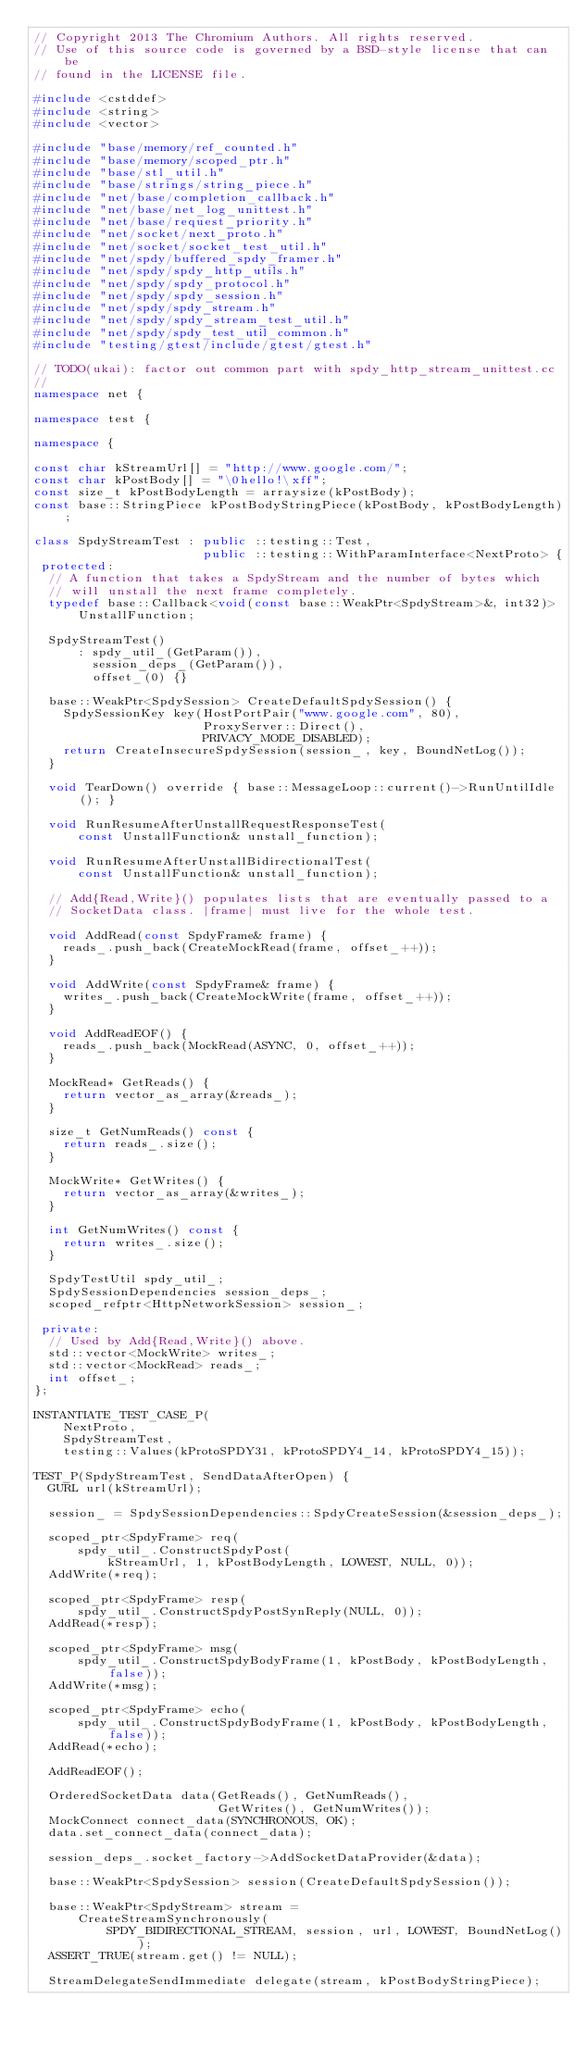Convert code to text. <code><loc_0><loc_0><loc_500><loc_500><_C++_>// Copyright 2013 The Chromium Authors. All rights reserved.
// Use of this source code is governed by a BSD-style license that can be
// found in the LICENSE file.

#include <cstddef>
#include <string>
#include <vector>

#include "base/memory/ref_counted.h"
#include "base/memory/scoped_ptr.h"
#include "base/stl_util.h"
#include "base/strings/string_piece.h"
#include "net/base/completion_callback.h"
#include "net/base/net_log_unittest.h"
#include "net/base/request_priority.h"
#include "net/socket/next_proto.h"
#include "net/socket/socket_test_util.h"
#include "net/spdy/buffered_spdy_framer.h"
#include "net/spdy/spdy_http_utils.h"
#include "net/spdy/spdy_protocol.h"
#include "net/spdy/spdy_session.h"
#include "net/spdy/spdy_stream.h"
#include "net/spdy/spdy_stream_test_util.h"
#include "net/spdy/spdy_test_util_common.h"
#include "testing/gtest/include/gtest/gtest.h"

// TODO(ukai): factor out common part with spdy_http_stream_unittest.cc
//
namespace net {

namespace test {

namespace {

const char kStreamUrl[] = "http://www.google.com/";
const char kPostBody[] = "\0hello!\xff";
const size_t kPostBodyLength = arraysize(kPostBody);
const base::StringPiece kPostBodyStringPiece(kPostBody, kPostBodyLength);

class SpdyStreamTest : public ::testing::Test,
                       public ::testing::WithParamInterface<NextProto> {
 protected:
  // A function that takes a SpdyStream and the number of bytes which
  // will unstall the next frame completely.
  typedef base::Callback<void(const base::WeakPtr<SpdyStream>&, int32)>
      UnstallFunction;

  SpdyStreamTest()
      : spdy_util_(GetParam()),
        session_deps_(GetParam()),
        offset_(0) {}

  base::WeakPtr<SpdySession> CreateDefaultSpdySession() {
    SpdySessionKey key(HostPortPair("www.google.com", 80),
                       ProxyServer::Direct(),
                       PRIVACY_MODE_DISABLED);
    return CreateInsecureSpdySession(session_, key, BoundNetLog());
  }

  void TearDown() override { base::MessageLoop::current()->RunUntilIdle(); }

  void RunResumeAfterUnstallRequestResponseTest(
      const UnstallFunction& unstall_function);

  void RunResumeAfterUnstallBidirectionalTest(
      const UnstallFunction& unstall_function);

  // Add{Read,Write}() populates lists that are eventually passed to a
  // SocketData class. |frame| must live for the whole test.

  void AddRead(const SpdyFrame& frame) {
    reads_.push_back(CreateMockRead(frame, offset_++));
  }

  void AddWrite(const SpdyFrame& frame) {
    writes_.push_back(CreateMockWrite(frame, offset_++));
  }

  void AddReadEOF() {
    reads_.push_back(MockRead(ASYNC, 0, offset_++));
  }

  MockRead* GetReads() {
    return vector_as_array(&reads_);
  }

  size_t GetNumReads() const {
    return reads_.size();
  }

  MockWrite* GetWrites() {
    return vector_as_array(&writes_);
  }

  int GetNumWrites() const {
    return writes_.size();
  }

  SpdyTestUtil spdy_util_;
  SpdySessionDependencies session_deps_;
  scoped_refptr<HttpNetworkSession> session_;

 private:
  // Used by Add{Read,Write}() above.
  std::vector<MockWrite> writes_;
  std::vector<MockRead> reads_;
  int offset_;
};

INSTANTIATE_TEST_CASE_P(
    NextProto,
    SpdyStreamTest,
    testing::Values(kProtoSPDY31, kProtoSPDY4_14, kProtoSPDY4_15));

TEST_P(SpdyStreamTest, SendDataAfterOpen) {
  GURL url(kStreamUrl);

  session_ = SpdySessionDependencies::SpdyCreateSession(&session_deps_);

  scoped_ptr<SpdyFrame> req(
      spdy_util_.ConstructSpdyPost(
          kStreamUrl, 1, kPostBodyLength, LOWEST, NULL, 0));
  AddWrite(*req);

  scoped_ptr<SpdyFrame> resp(
      spdy_util_.ConstructSpdyPostSynReply(NULL, 0));
  AddRead(*resp);

  scoped_ptr<SpdyFrame> msg(
      spdy_util_.ConstructSpdyBodyFrame(1, kPostBody, kPostBodyLength, false));
  AddWrite(*msg);

  scoped_ptr<SpdyFrame> echo(
      spdy_util_.ConstructSpdyBodyFrame(1, kPostBody, kPostBodyLength, false));
  AddRead(*echo);

  AddReadEOF();

  OrderedSocketData data(GetReads(), GetNumReads(),
                         GetWrites(), GetNumWrites());
  MockConnect connect_data(SYNCHRONOUS, OK);
  data.set_connect_data(connect_data);

  session_deps_.socket_factory->AddSocketDataProvider(&data);

  base::WeakPtr<SpdySession> session(CreateDefaultSpdySession());

  base::WeakPtr<SpdyStream> stream =
      CreateStreamSynchronously(
          SPDY_BIDIRECTIONAL_STREAM, session, url, LOWEST, BoundNetLog());
  ASSERT_TRUE(stream.get() != NULL);

  StreamDelegateSendImmediate delegate(stream, kPostBodyStringPiece);</code> 